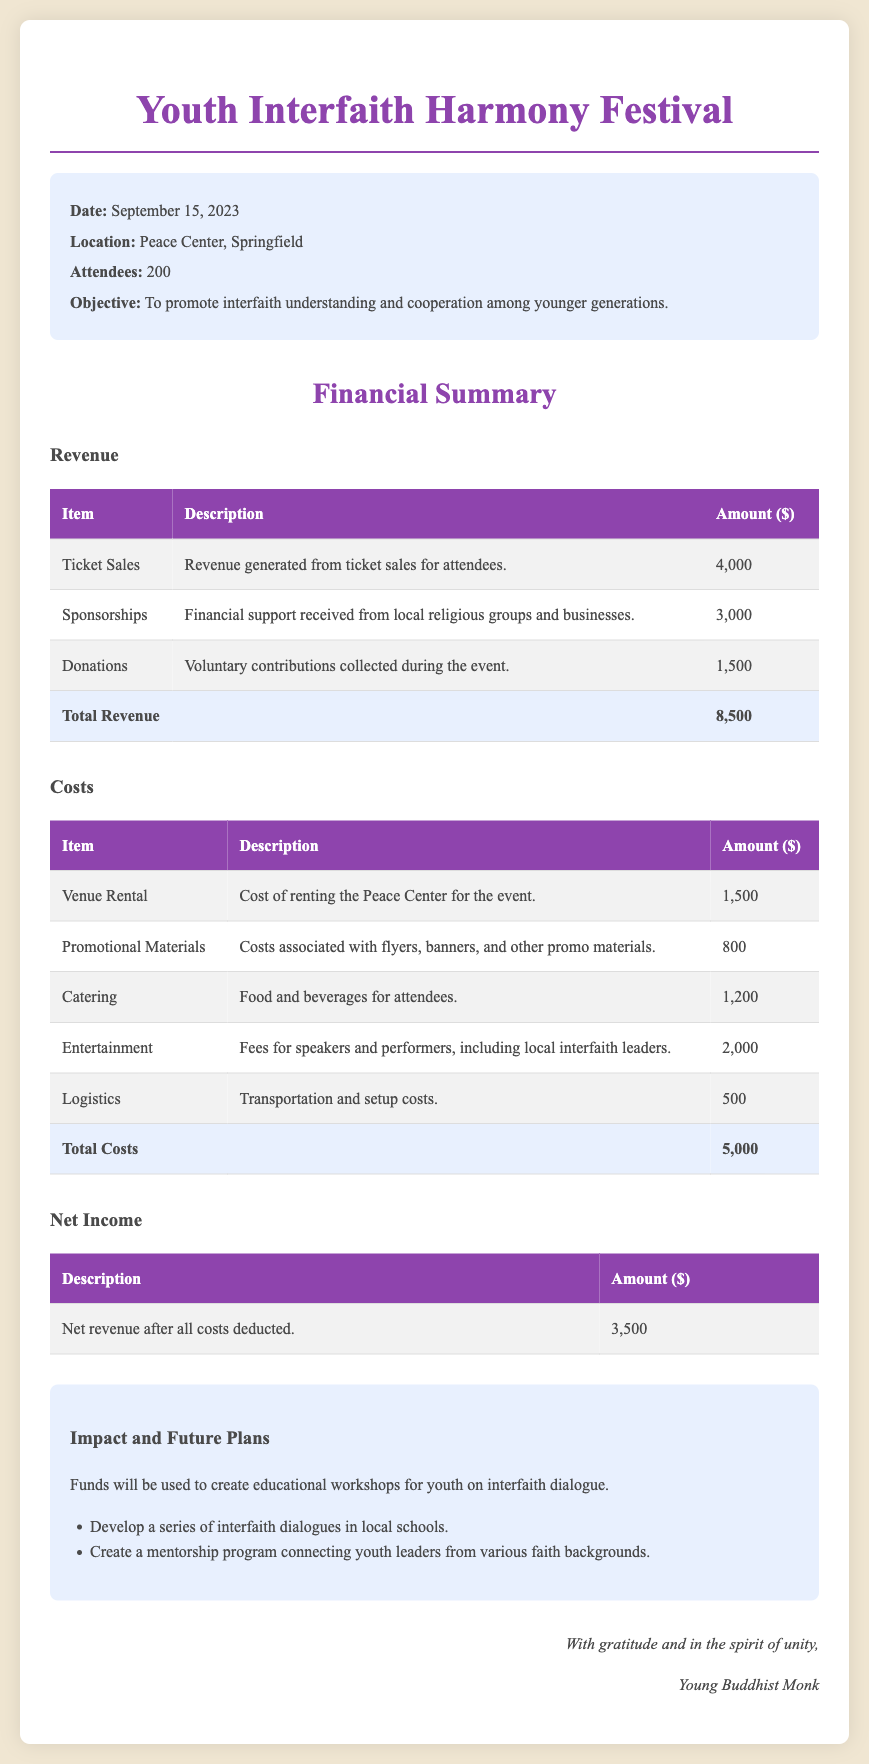What is the date of the event? The date of the event is stated at the beginning of the summary section.
Answer: September 15, 2023 What was the total revenue generated? The total revenue is the sum of ticket sales, sponsorships, and donations, as shown in the financial summary.
Answer: 8,500 How many attendees were there? The number of attendees is mentioned in the summary section of the document.
Answer: 200 What was the cost for catering? The cost for catering is specified in the costs table of the document.
Answer: 1,200 What is the net income after all costs? The net income is calculated as total revenue minus total costs, as shown in the net income section.
Answer: 3,500 Which item had the highest cost? The highest cost item can be determined by comparing all costs listed in the document.
Answer: Entertainment What will the funds be used for? The document states the intended use of the funds in the impact section.
Answer: Educational workshops What is one future plan mentioned? The future plans include specific initiatives outlined in the impact section of the document.
Answer: Develop a series of interfaith dialogues in local schools 